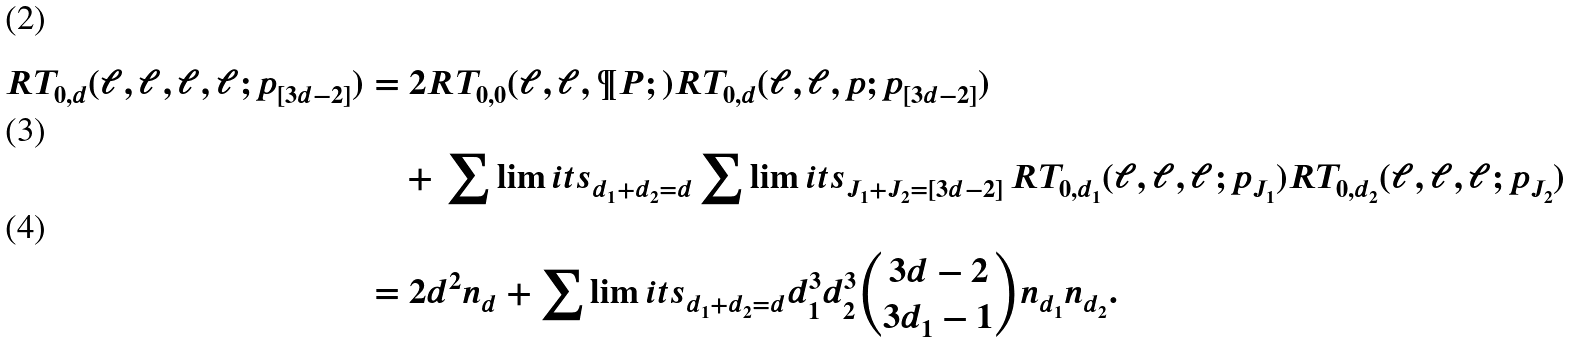Convert formula to latex. <formula><loc_0><loc_0><loc_500><loc_500>R T _ { 0 , d } ( \ell , \ell , \ell , \ell ; p _ { [ 3 d - 2 ] } ) & = 2 R T _ { 0 , 0 } ( \ell , \ell , \P P ; ) R T _ { 0 , d } ( \ell , \ell , p ; p _ { [ 3 d - 2 ] } ) \\ & \quad + \, \sum \lim i t s _ { d _ { 1 } + d _ { 2 } = d } \sum \lim i t s _ { J _ { 1 } + J _ { 2 } = [ 3 d - 2 ] } \, R T _ { 0 , d _ { 1 } } ( \ell , \ell , \ell ; p _ { J _ { 1 } } ) R T _ { 0 , d _ { 2 } } ( \ell , \ell , \ell ; p _ { J _ { 2 } } ) \\ & = 2 d ^ { 2 } n _ { d } + \sum \lim i t s _ { d _ { 1 } + d _ { 2 } = d } d _ { 1 } ^ { 3 } d _ { 2 } ^ { 3 } \binom { 3 d - 2 } { 3 d _ { 1 } - 1 } n _ { d _ { 1 } } n _ { d _ { 2 } } .</formula> 